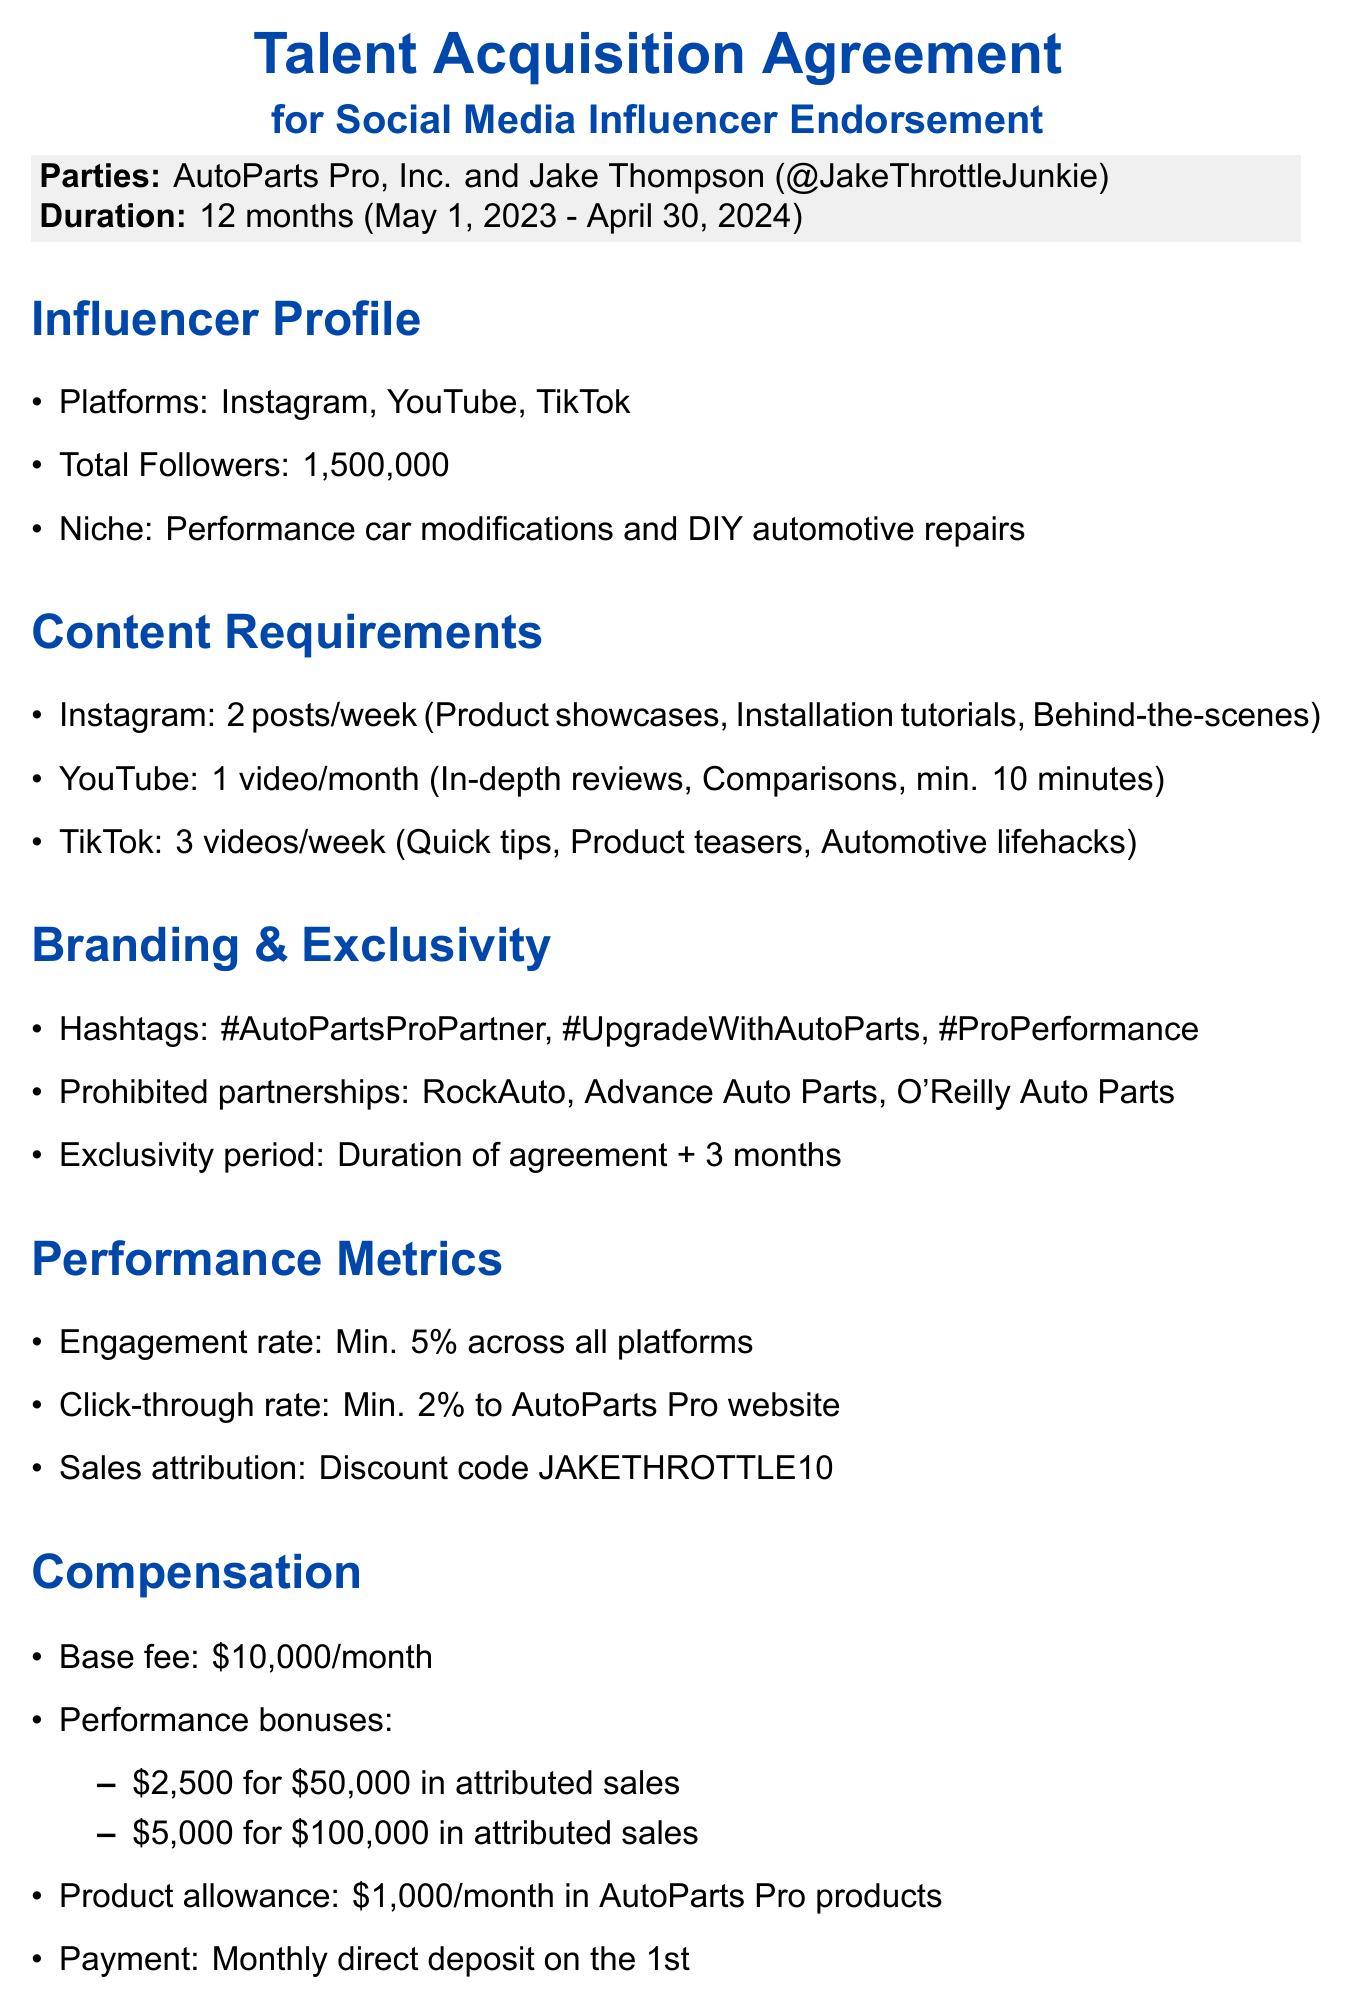what is the name of the influencer? The influencer's name mentioned in the document is Jake Thompson.
Answer: Jake Thompson how long is the agreement duration? The duration of the agreement is specified in the document as 12 months.
Answer: 12 months what is the base fee per month? The document specifies the base fee that AutoParts Pro will pay the influencer each month.
Answer: $10,000 how many Instagram posts are required per week? The frequency of Instagram posts required from the influencer is listed in the document.
Answer: 2 per week what is the minimum length for YouTube videos? The document states a specific requirement for the minimum length of videos on YouTube.
Answer: 10 minutes how many TikTok videos are required per week? The document outlines the weekly requirement for TikTok videos from the influencer.
Answer: 3 per week what is the click-through rate threshold for performance metrics? The document provides a threshold for click-through rate that the influencer must meet.
Answer: Minimum 2% what payment method will be used for payments? The document indicates the method of payment for the influencer's fees.
Answer: Direct deposit what is the notice period for termination? The required notice period for termination by either party is detailed in the document.
Answer: 30 days which state governs the agreement? The governing law applicable to the agreement is mentioned in the document.
Answer: Michigan 